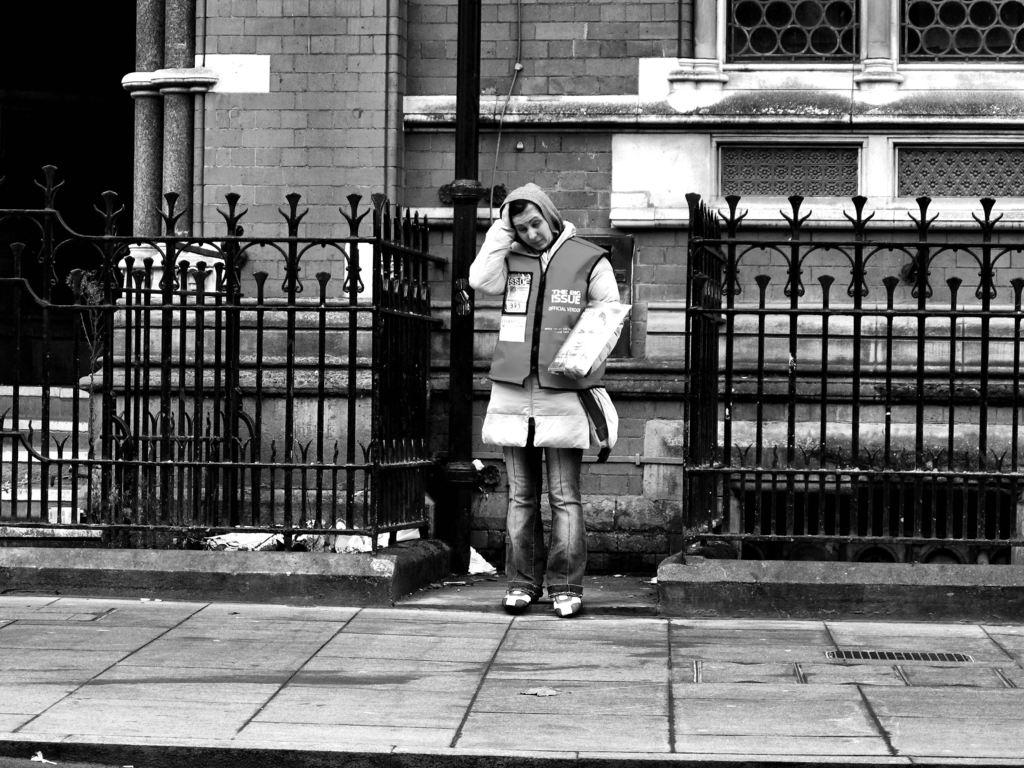What is the main subject of the image? There is a person standing in the center of the image. What can be seen in the background of the image? There is a building in the background of the image. What might be used for safety or support in the image? There are railings at the bottom of the image. What type of spoon is being used for the person's voyage in the image? There is no voyage or spoon present in the image; it features a person standing with a building in the background and railings at the bottom. 